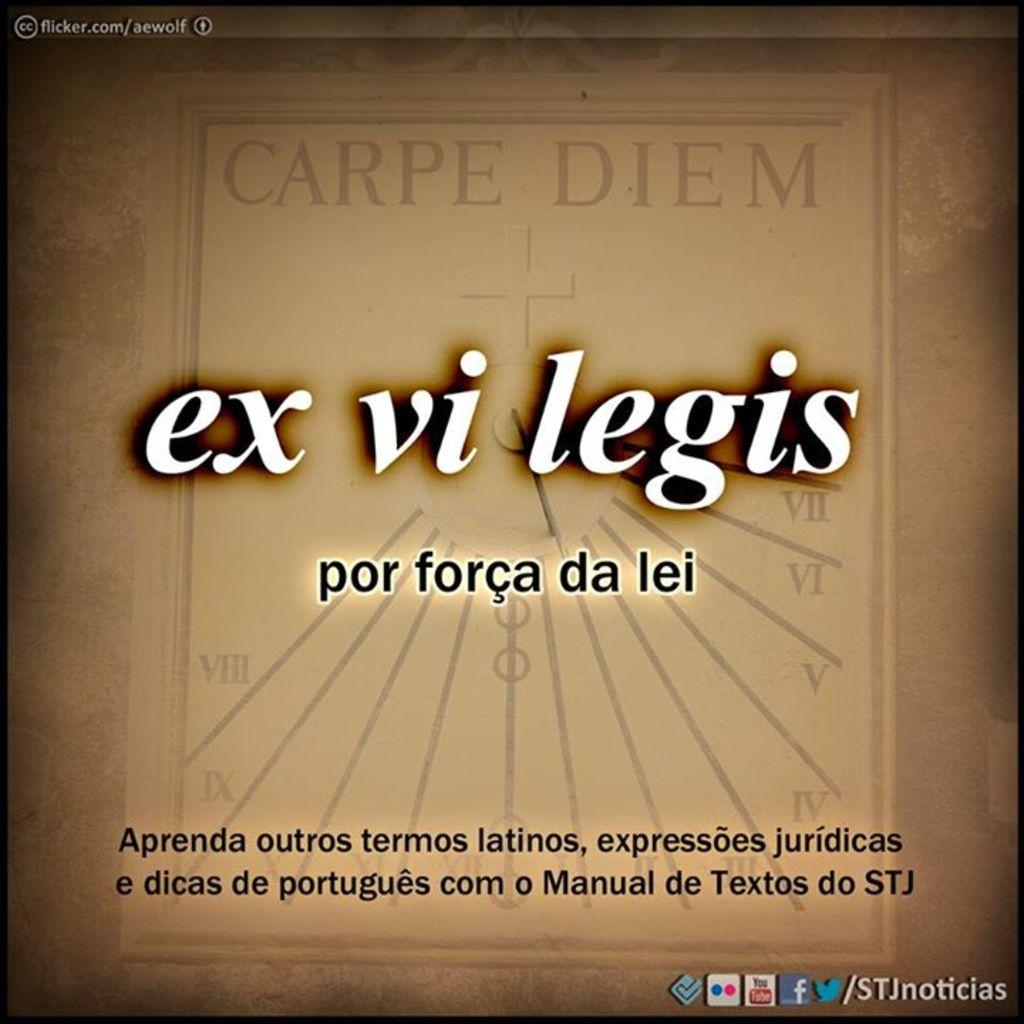<image>
Present a compact description of the photo's key features. Online advertisment for ex vi legism, they have facebook twitter youtube and more. 